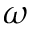Convert formula to latex. <formula><loc_0><loc_0><loc_500><loc_500>\omega</formula> 